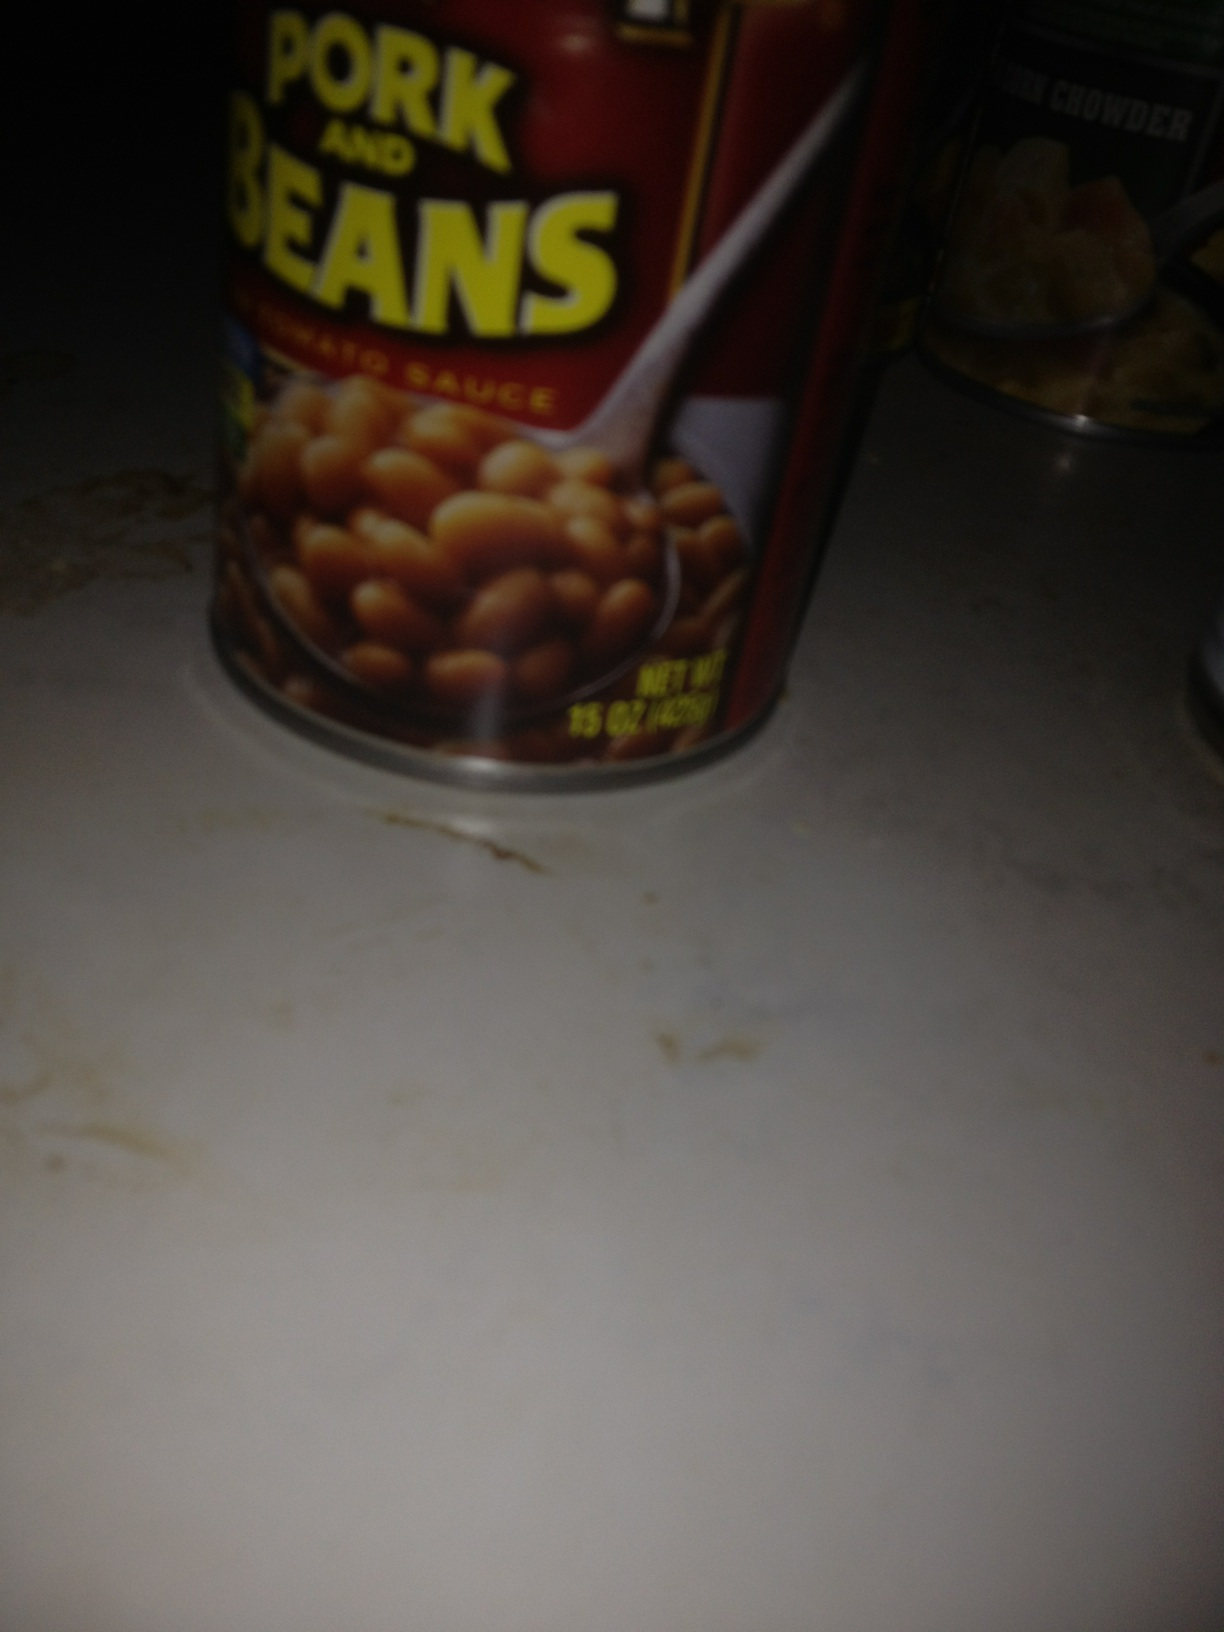I like you to tell me what these two cans are sitting here The can in the foreground is of Pork and Beans in Tomato Sauce. The can in the background appears to be a can of New England Clam Chowder. 